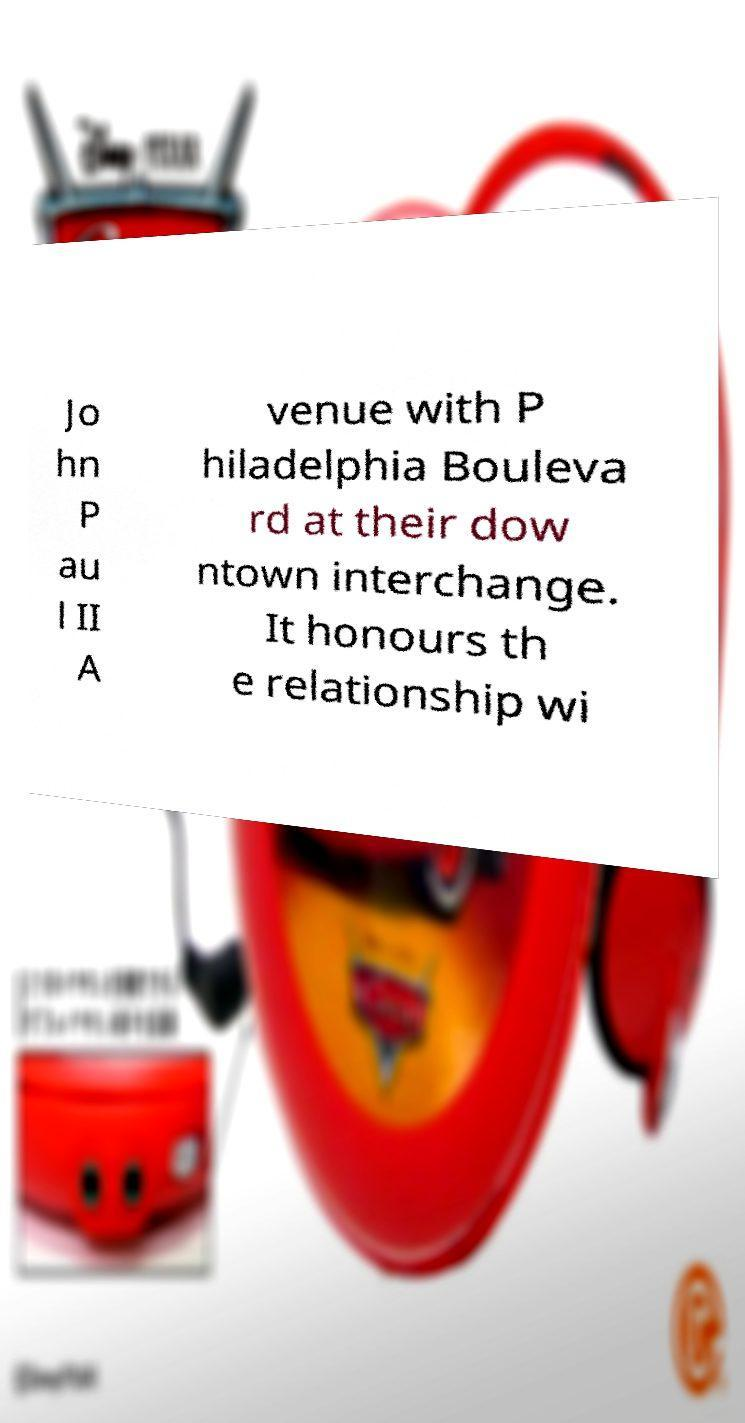What messages or text are displayed in this image? I need them in a readable, typed format. Jo hn P au l II A venue with P hiladelphia Bouleva rd at their dow ntown interchange. It honours th e relationship wi 